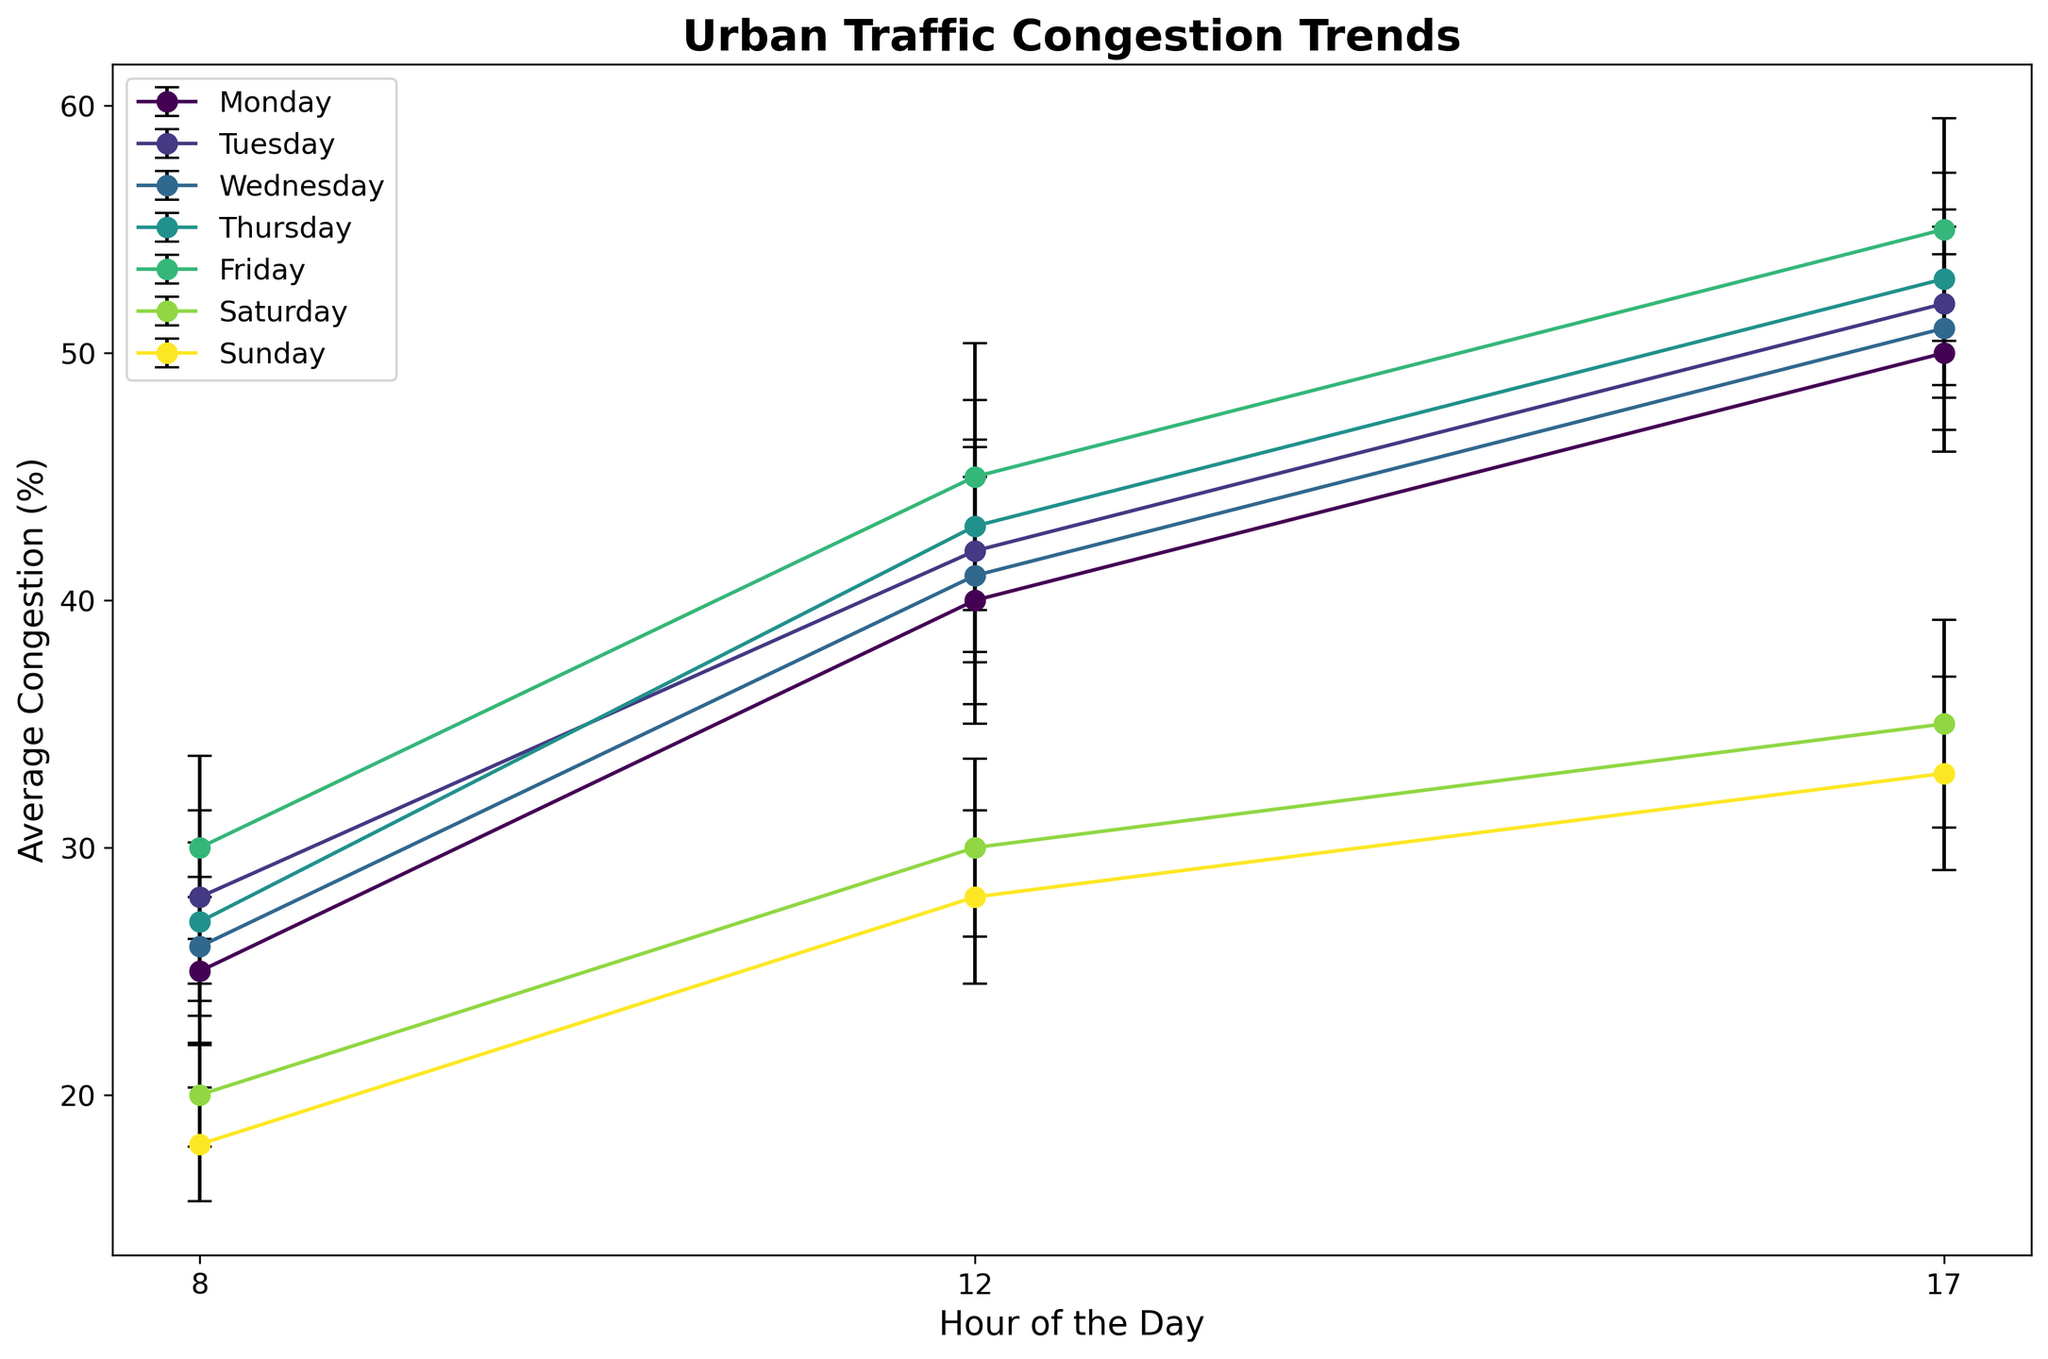What's the average congestion level at 8 AM for the weekdays (Monday to Friday)? Extract the 8 AM congestion levels for Monday, Tuesday, Wednesday, Thursday, and Friday. The values are 25, 28, 26, 27, and 30 respectively. The average is calculated as (25 + 28 + 26 + 27 + 30) / 5 = 27.2
Answer: 27.2 Which day shows the highest average congestion at 12 PM? Look at the congestion levels for each day at 12 PM. The values are: Monday - 40, Tuesday - 42, Wednesday - 41, Thursday - 43, Friday - 45, Saturday - 30, Sunday - 28. The highest value is 45 on Friday.
Answer: Friday At 5 PM, compare the congestion on Monday and Friday. Which day has higher congestion? Measure the congestion levels at 5 PM for Monday (50) and Friday (55). Friday's congestion (55) is higher than Monday's (50).
Answer: Friday What's the difference in congestion levels at 12 PM between Wednesday and Thursday? Find the congestion levels at 12 PM for Wednesday (41) and Thursday (43). The difference is 43 - 41 = 2.
Answer: 2 Which day has the smallest variation (standard deviation) in congestion levels at 8 AM? Look at the standard deviations at 8 AM for each day: Monday - 3, Tuesday - 3.5, Wednesday - 2.8, Thursday - 3.2, Friday - 3.7, Saturday - 2.1, Sunday - 2.3. The smallest is Saturday with 2.1.
Answer: Saturday Compare the error margins at 5 PM on Monday and Thursday. Which day has a larger error margin? The error margins (standard deviations) at 5 PM are Monday - 4, Thursday - 4.3. Thursday has the larger error margin (4.3 vs 4).
Answer: Thursday Calculate the total congestion at 12 PM for the weekend (Saturday and Sunday). Check the congestion values at 12 PM for Saturday (30) and Sunday (28). The total is 30 + 28 = 58.
Answer: 58 What's the highest congestion level throughout the week and at what time does it occur? Look at all congestion values and identify the maximum value. The highest is 55 at 5 PM on Friday.
Answer: 55 at 5 PM on Friday Which day shows the most significant congestion increase from 8 AM to 5 PM? Calculate the differences in congestion from 8 AM to 5 PM for each day: 
Monday: 50 - 25 = 25
Tuesday: 52 - 28 = 24
Wednesday: 51 - 26 = 25
Thursday: 53 - 27 = 26
Friday: 55 - 30 = 25
Saturday: 35 - 20 = 15
Sunday: 33 - 18 = 15
Thursday has the highest increase (26).
Answer: Thursday 